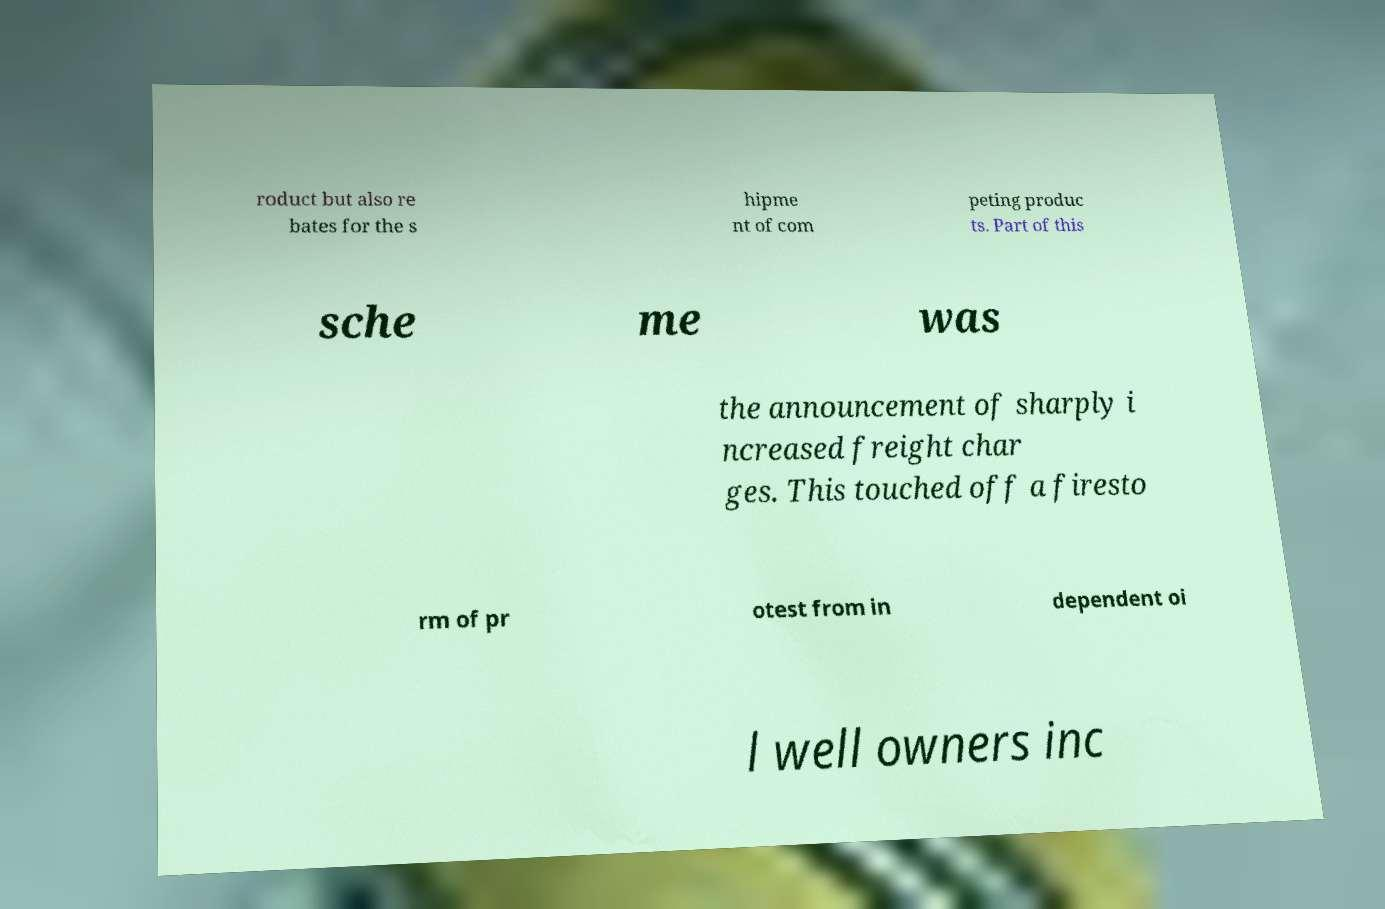There's text embedded in this image that I need extracted. Can you transcribe it verbatim? roduct but also re bates for the s hipme nt of com peting produc ts. Part of this sche me was the announcement of sharply i ncreased freight char ges. This touched off a firesto rm of pr otest from in dependent oi l well owners inc 